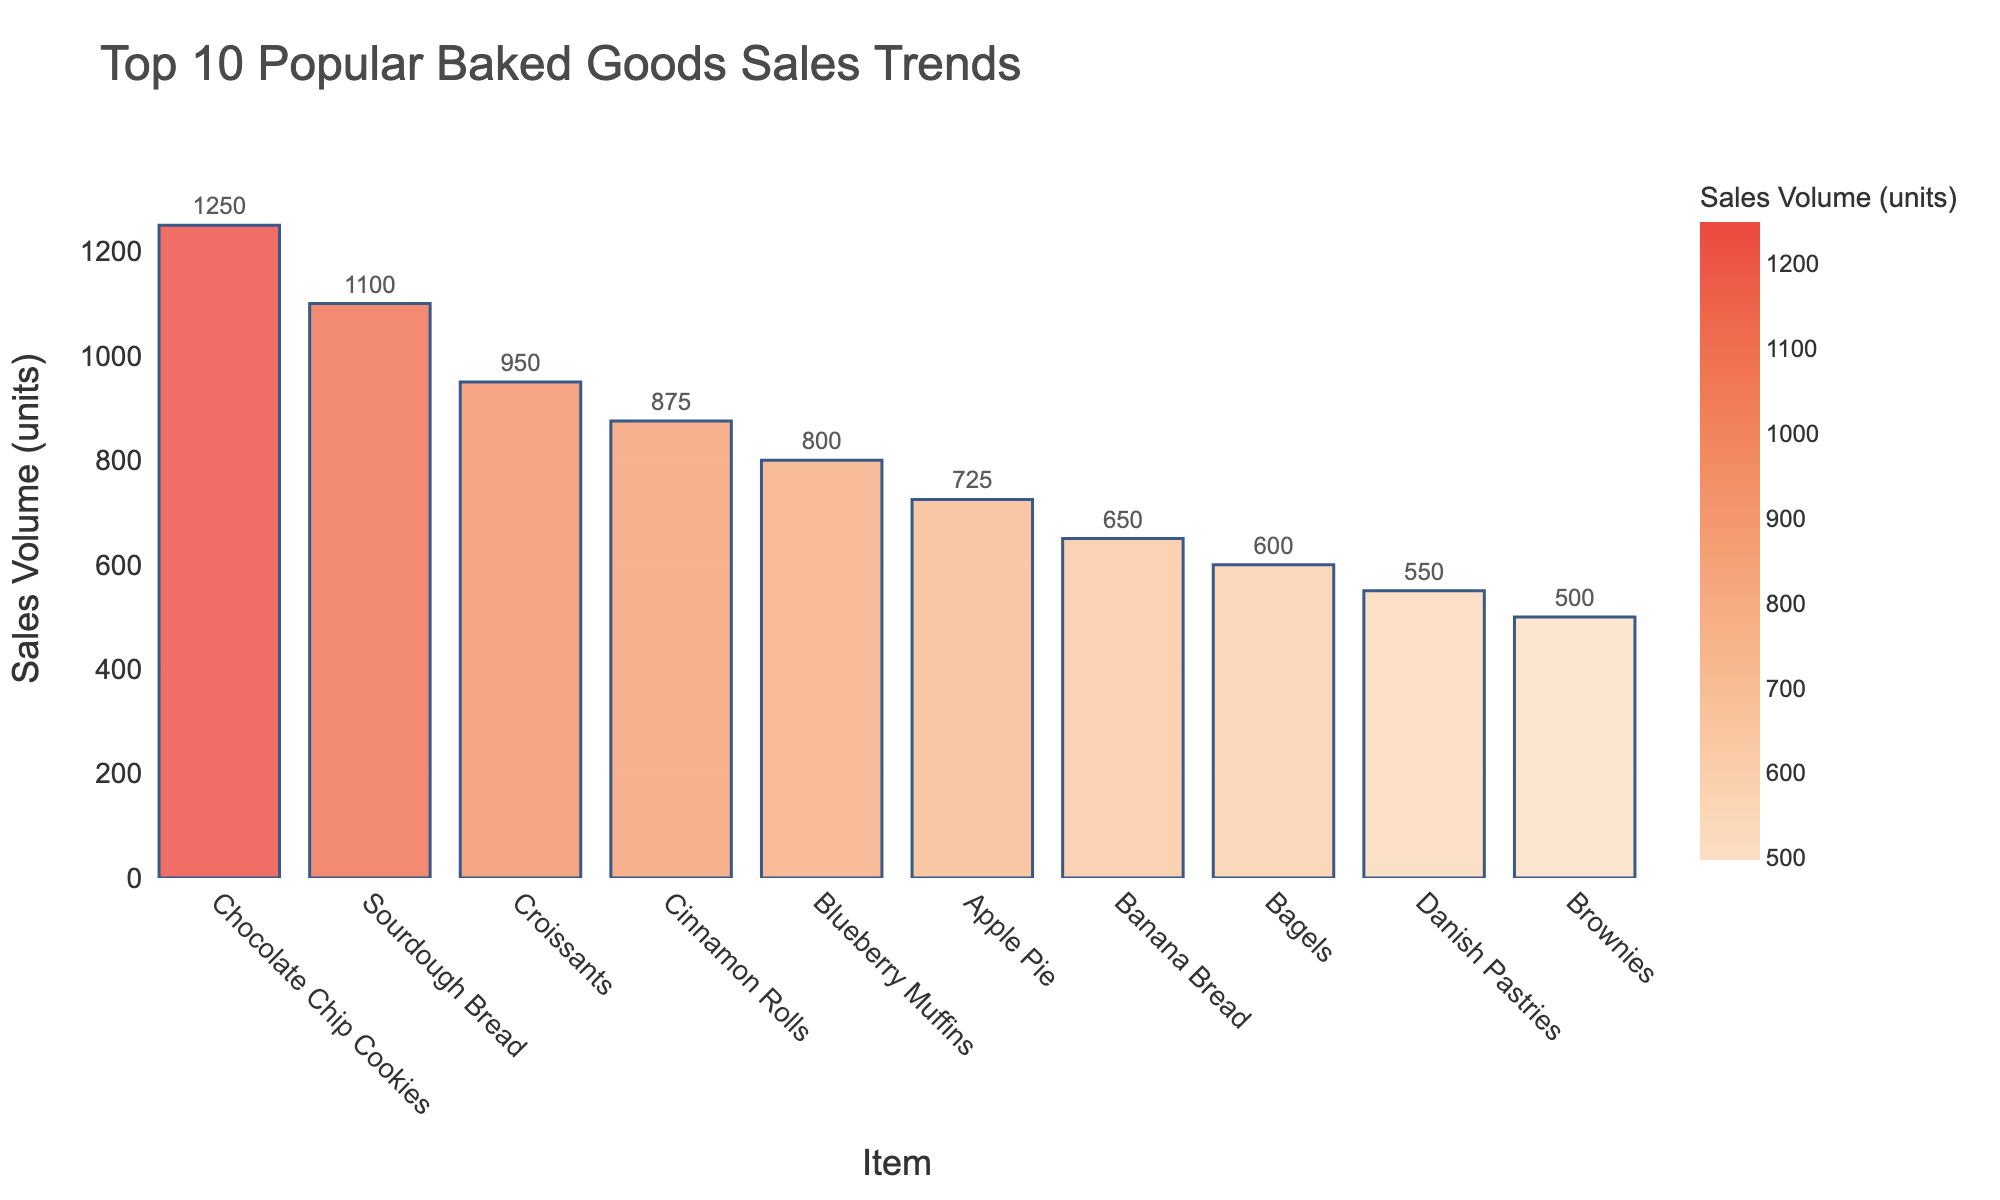Which baked good has the highest sales volume? By looking at the figure, the tallest bar represents the item with the highest sales volume.
Answer: Chocolate Chip Cookies Which two baked goods have the closest sales volumes? From the figure, "Croissants" and "Cinnamon Rolls" have bars of very similar height, indicating similar sales volumes.
Answer: Croissants and Cinnamon Rolls What is the total sales volume for the top three baked goods? The figure shows the sales volumes for the top three items as Chocolate Chip Cookies (1250), Sourdough Bread (1100), and Croissants (950). Summing these gives 1250 + 1100 + 950.
Answer: 3300 Which baked good has higher sales volumes: Blueberry Muffins or Apple Pie? By comparing the bar heights for "Blueberry Muffins" and "Apple Pie," the bar for Blueberry Muffins is taller, indicating higher sales.
Answer: Blueberry Muffins What is the difference in sales volume between the highest and the lowest item in the top 10? The figure shows the highest sales volume for Chocolate Chip Cookies (1250) and the lowest in the top 10 for Brownies (500). The difference is 1250 - 500.
Answer: 750 Which baked good ranks 5th in sales volume? By counting the bars from the tallest to the shortest, the 5th item is "Blueberry Muffins."
Answer: Blueberry Muffins What is the average sales volume for the top 10 baked goods? The total sales volume for the top 10 items is (1250 + 1100 + 950 + 875 + 800 + 725 + 650 + 600 + 550 + 500). Dividing this sum by 10 gives the average. (Total: 8000, Average: 8000 / 10).
Answer: 800 Between "Bagels" and "Scones," which has lower sales volume? By visually comparing the bars for "Bagels" and "Scones," Scones has a shorter bar, indicating lower sales volume.
Answer: Scones What percentage of the top 10 sales does the best-selling item represent? The best-selling item is Chocolate Chip Cookies (1250). The total sales for the top 10 items are 8000. The percentage is (1250 / 8000) * 100.
Answer: 15.625% Are Danish Pastries in the top 10 for sales volume? By scanning the bars for the top 10 baked goods, Danish Pastries is one of the items listed.
Answer: Yes 